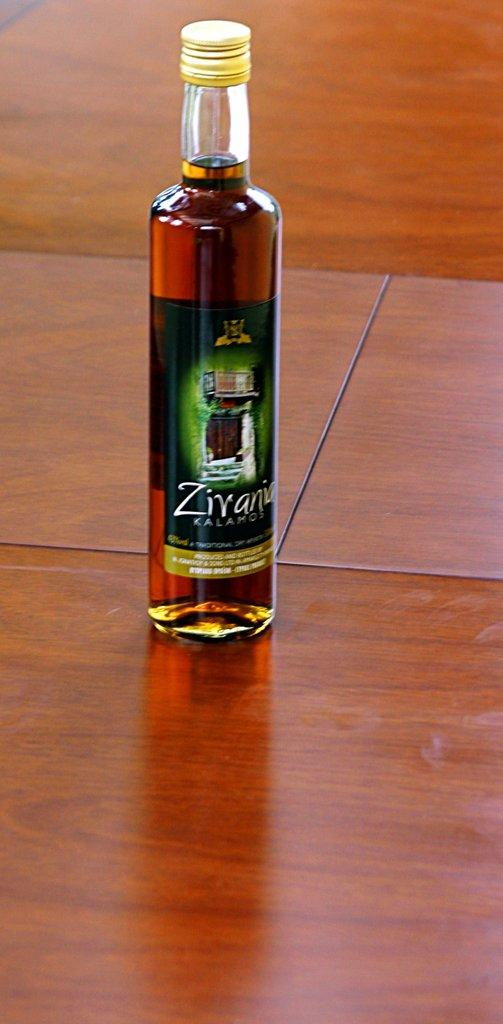<image>
Share a concise interpretation of the image provided. a full bottle of Zirania Kalamos on a wood table 